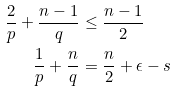Convert formula to latex. <formula><loc_0><loc_0><loc_500><loc_500>\frac { 2 } { p } + \frac { n - 1 } { q } & \leq \frac { n - 1 } { 2 } \\ \frac { 1 } { p } + \frac { n } { q } & = \frac { n } { 2 } + \epsilon - s</formula> 